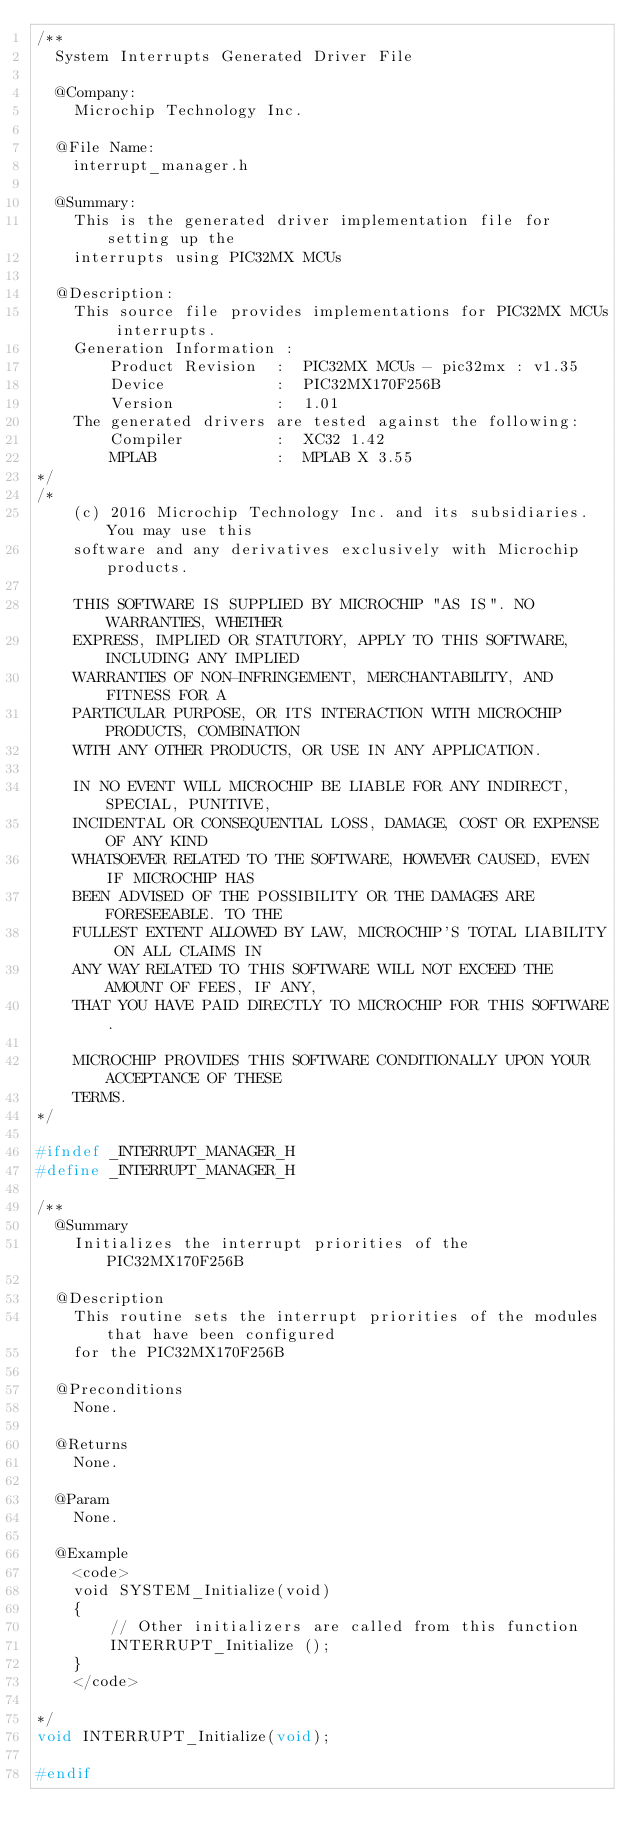<code> <loc_0><loc_0><loc_500><loc_500><_C_>/**
  System Interrupts Generated Driver File 

  @Company:
    Microchip Technology Inc.

  @File Name:
    interrupt_manager.h

  @Summary:
    This is the generated driver implementation file for setting up the
    interrupts using PIC32MX MCUs

  @Description:
    This source file provides implementations for PIC32MX MCUs interrupts.
    Generation Information : 
        Product Revision  :  PIC32MX MCUs - pic32mx : v1.35
        Device            :  PIC32MX170F256B
        Version           :  1.01
    The generated drivers are tested against the following:
        Compiler          :  XC32 1.42
        MPLAB             :  MPLAB X 3.55
*/
/*
    (c) 2016 Microchip Technology Inc. and its subsidiaries. You may use this
    software and any derivatives exclusively with Microchip products.

    THIS SOFTWARE IS SUPPLIED BY MICROCHIP "AS IS". NO WARRANTIES, WHETHER
    EXPRESS, IMPLIED OR STATUTORY, APPLY TO THIS SOFTWARE, INCLUDING ANY IMPLIED
    WARRANTIES OF NON-INFRINGEMENT, MERCHANTABILITY, AND FITNESS FOR A
    PARTICULAR PURPOSE, OR ITS INTERACTION WITH MICROCHIP PRODUCTS, COMBINATION
    WITH ANY OTHER PRODUCTS, OR USE IN ANY APPLICATION.

    IN NO EVENT WILL MICROCHIP BE LIABLE FOR ANY INDIRECT, SPECIAL, PUNITIVE,
    INCIDENTAL OR CONSEQUENTIAL LOSS, DAMAGE, COST OR EXPENSE OF ANY KIND
    WHATSOEVER RELATED TO THE SOFTWARE, HOWEVER CAUSED, EVEN IF MICROCHIP HAS
    BEEN ADVISED OF THE POSSIBILITY OR THE DAMAGES ARE FORESEEABLE. TO THE
    FULLEST EXTENT ALLOWED BY LAW, MICROCHIP'S TOTAL LIABILITY ON ALL CLAIMS IN
    ANY WAY RELATED TO THIS SOFTWARE WILL NOT EXCEED THE AMOUNT OF FEES, IF ANY,
    THAT YOU HAVE PAID DIRECTLY TO MICROCHIP FOR THIS SOFTWARE.

    MICROCHIP PROVIDES THIS SOFTWARE CONDITIONALLY UPON YOUR ACCEPTANCE OF THESE
    TERMS.
*/

#ifndef _INTERRUPT_MANAGER_H
#define _INTERRUPT_MANAGER_H

/**
  @Summary
    Initializes the interrupt priorities of the PIC32MX170F256B

  @Description
    This routine sets the interrupt priorities of the modules that have been configured
    for the PIC32MX170F256B

  @Preconditions
    None.

  @Returns
    None.

  @Param
    None.

  @Example
    <code>
    void SYSTEM_Initialize(void)
    {
        // Other initializers are called from this function
        INTERRUPT_Initialize ();
    }
    </code>

*/
void INTERRUPT_Initialize(void);

#endif</code> 